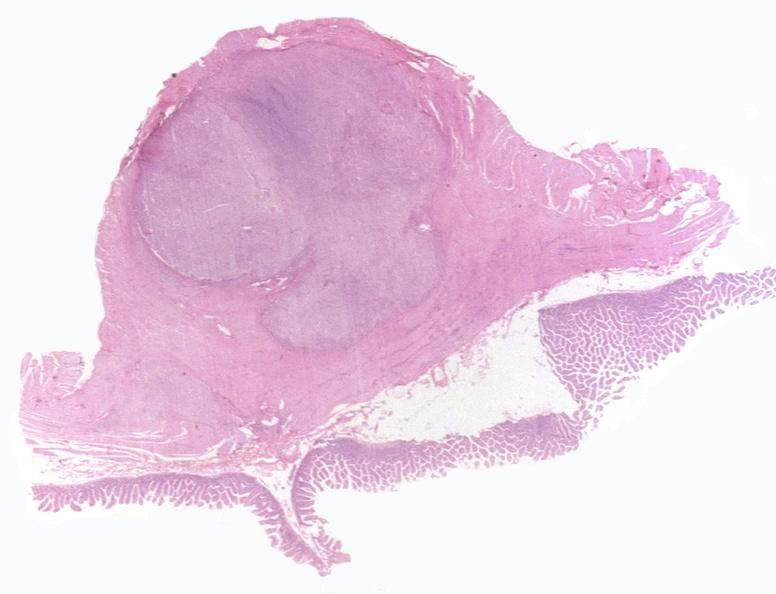where is this from?
Answer the question using a single word or phrase. Gastrointestinal system 